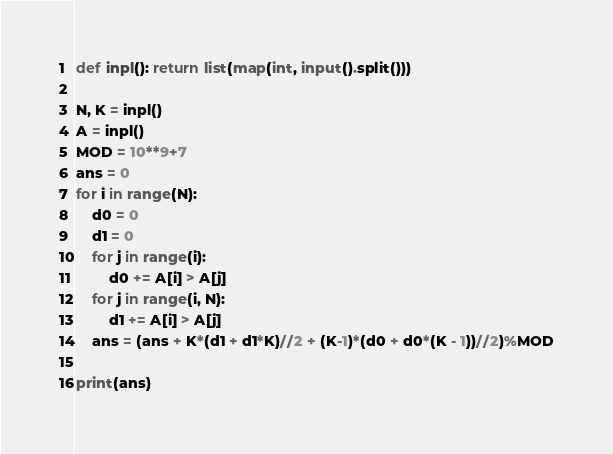<code> <loc_0><loc_0><loc_500><loc_500><_Python_>def inpl(): return list(map(int, input().split()))

N, K = inpl()
A = inpl()
MOD = 10**9+7
ans = 0
for i in range(N):
    d0 = 0
    d1 = 0
    for j in range(i):
        d0 += A[i] > A[j]
    for j in range(i, N):
        d1 += A[i] > A[j]
    ans = (ans + K*(d1 + d1*K)//2 + (K-1)*(d0 + d0*(K - 1))//2)%MOD

print(ans)</code> 